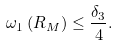Convert formula to latex. <formula><loc_0><loc_0><loc_500><loc_500>\omega _ { 1 } \left ( R _ { M } \right ) \leq \frac { \delta _ { 3 } } { 4 } .</formula> 